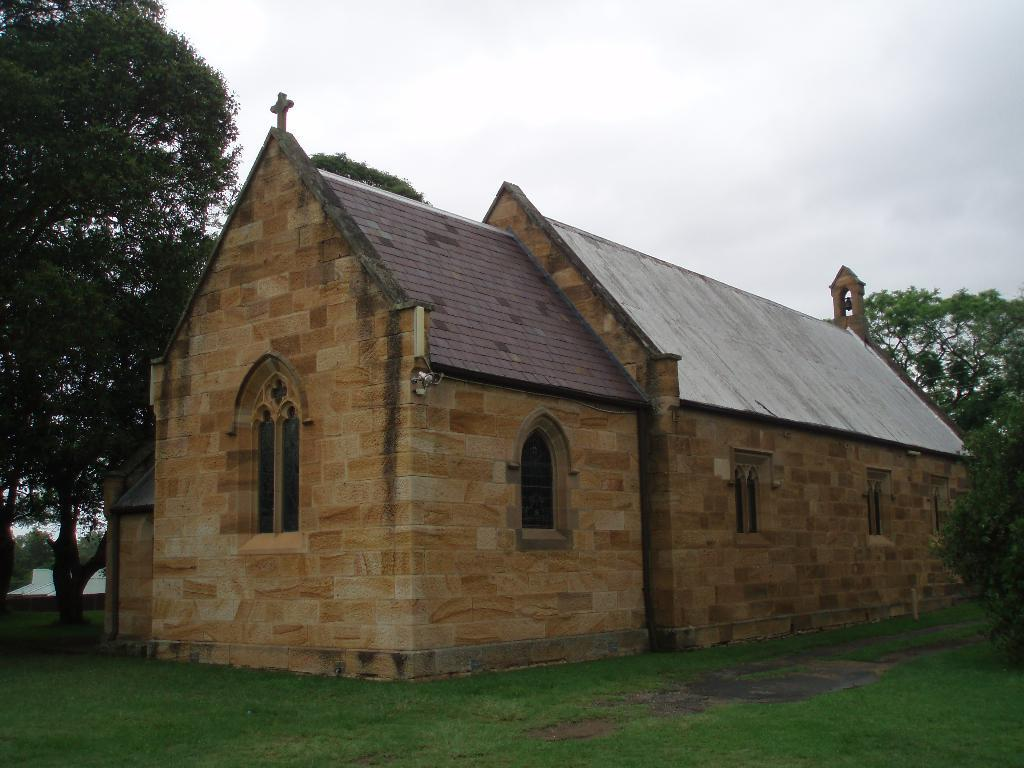What type of vegetation is present on the ground in the front of the image? There is grass on the ground in the front of the image. What structure is located in the center of the image? There is a house in the center of the image. What can be seen in the background of the image? There are trees and water visible in the background of the image. How would you describe the sky in the image? The sky is cloudy in the image. What type of cream can be seen dripping from the trees in the image? There is no cream present in the image, nor is there any dripping substance from the trees. How many clovers are visible in the image? There is no mention of clovers in the provided facts, so it cannot be determined if any are present in the image. 